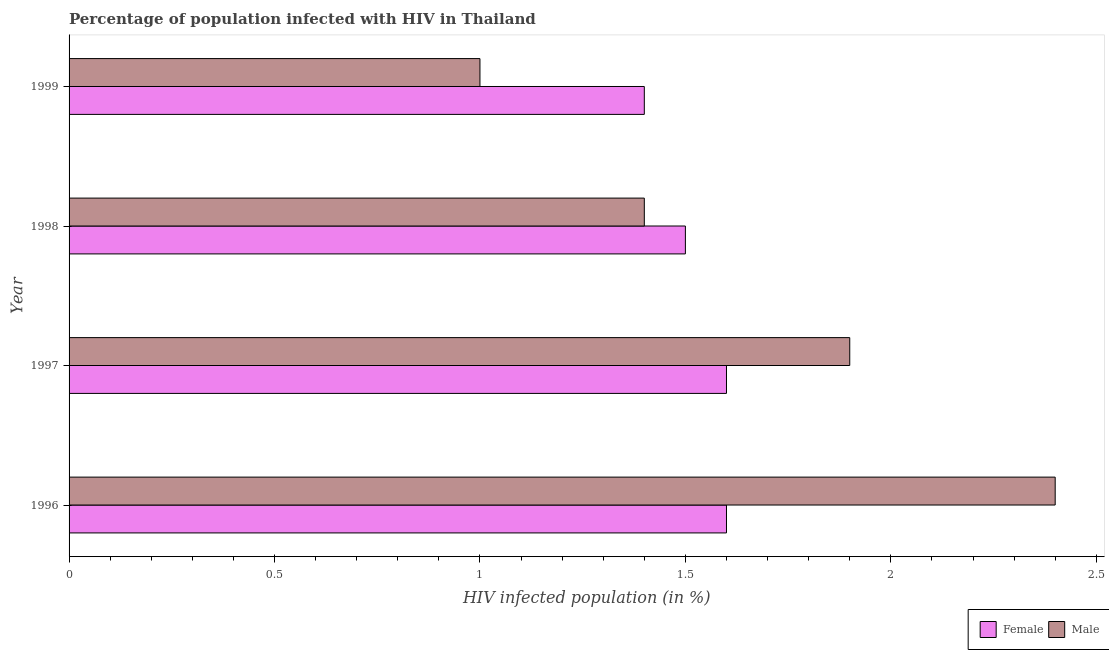How many groups of bars are there?
Give a very brief answer. 4. Are the number of bars on each tick of the Y-axis equal?
Your answer should be compact. Yes. What is the percentage of males who are infected with hiv in 1997?
Make the answer very short. 1.9. Across all years, what is the maximum percentage of females who are infected with hiv?
Your answer should be compact. 1.6. In which year was the percentage of females who are infected with hiv maximum?
Your response must be concise. 1996. In which year was the percentage of males who are infected with hiv minimum?
Offer a very short reply. 1999. What is the total percentage of males who are infected with hiv in the graph?
Your response must be concise. 6.7. What is the difference between the percentage of males who are infected with hiv in 1998 and the percentage of females who are infected with hiv in 1996?
Your answer should be very brief. -0.2. What is the average percentage of females who are infected with hiv per year?
Provide a succinct answer. 1.52. In the year 1998, what is the difference between the percentage of females who are infected with hiv and percentage of males who are infected with hiv?
Offer a very short reply. 0.1. In how many years, is the percentage of females who are infected with hiv greater than 2.4 %?
Provide a short and direct response. 0. What is the ratio of the percentage of females who are infected with hiv in 1996 to that in 1999?
Offer a terse response. 1.14. Is the percentage of males who are infected with hiv in 1997 less than that in 1999?
Make the answer very short. No. In how many years, is the percentage of males who are infected with hiv greater than the average percentage of males who are infected with hiv taken over all years?
Your answer should be compact. 2. How many years are there in the graph?
Provide a short and direct response. 4. Are the values on the major ticks of X-axis written in scientific E-notation?
Offer a very short reply. No. Does the graph contain any zero values?
Give a very brief answer. No. Does the graph contain grids?
Offer a terse response. No. How are the legend labels stacked?
Provide a short and direct response. Horizontal. What is the title of the graph?
Your answer should be very brief. Percentage of population infected with HIV in Thailand. Does "Broad money growth" appear as one of the legend labels in the graph?
Make the answer very short. No. What is the label or title of the X-axis?
Ensure brevity in your answer.  HIV infected population (in %). What is the label or title of the Y-axis?
Your answer should be compact. Year. What is the HIV infected population (in %) of Male in 1997?
Give a very brief answer. 1.9. What is the HIV infected population (in %) in Male in 1998?
Your response must be concise. 1.4. What is the HIV infected population (in %) of Female in 1999?
Make the answer very short. 1.4. Across all years, what is the minimum HIV infected population (in %) in Female?
Your answer should be compact. 1.4. What is the difference between the HIV infected population (in %) of Female in 1996 and that in 1997?
Your response must be concise. 0. What is the difference between the HIV infected population (in %) in Male in 1996 and that in 1998?
Ensure brevity in your answer.  1. What is the difference between the HIV infected population (in %) of Female in 1997 and that in 1998?
Give a very brief answer. 0.1. What is the difference between the HIV infected population (in %) in Male in 1997 and that in 1999?
Provide a short and direct response. 0.9. What is the difference between the HIV infected population (in %) in Male in 1998 and that in 1999?
Offer a very short reply. 0.4. What is the difference between the HIV infected population (in %) of Female in 1996 and the HIV infected population (in %) of Male in 1999?
Offer a very short reply. 0.6. What is the difference between the HIV infected population (in %) of Female in 1998 and the HIV infected population (in %) of Male in 1999?
Your answer should be very brief. 0.5. What is the average HIV infected population (in %) in Female per year?
Provide a succinct answer. 1.52. What is the average HIV infected population (in %) in Male per year?
Your answer should be very brief. 1.68. What is the ratio of the HIV infected population (in %) in Female in 1996 to that in 1997?
Your answer should be very brief. 1. What is the ratio of the HIV infected population (in %) of Male in 1996 to that in 1997?
Make the answer very short. 1.26. What is the ratio of the HIV infected population (in %) in Female in 1996 to that in 1998?
Your answer should be compact. 1.07. What is the ratio of the HIV infected population (in %) in Male in 1996 to that in 1998?
Your answer should be very brief. 1.71. What is the ratio of the HIV infected population (in %) of Female in 1996 to that in 1999?
Your response must be concise. 1.14. What is the ratio of the HIV infected population (in %) in Female in 1997 to that in 1998?
Make the answer very short. 1.07. What is the ratio of the HIV infected population (in %) in Male in 1997 to that in 1998?
Provide a succinct answer. 1.36. What is the ratio of the HIV infected population (in %) in Female in 1997 to that in 1999?
Keep it short and to the point. 1.14. What is the ratio of the HIV infected population (in %) of Male in 1997 to that in 1999?
Keep it short and to the point. 1.9. What is the ratio of the HIV infected population (in %) of Female in 1998 to that in 1999?
Provide a short and direct response. 1.07. What is the difference between the highest and the second highest HIV infected population (in %) of Female?
Provide a short and direct response. 0. What is the difference between the highest and the second highest HIV infected population (in %) of Male?
Your response must be concise. 0.5. What is the difference between the highest and the lowest HIV infected population (in %) in Female?
Your answer should be very brief. 0.2. What is the difference between the highest and the lowest HIV infected population (in %) in Male?
Your answer should be very brief. 1.4. 